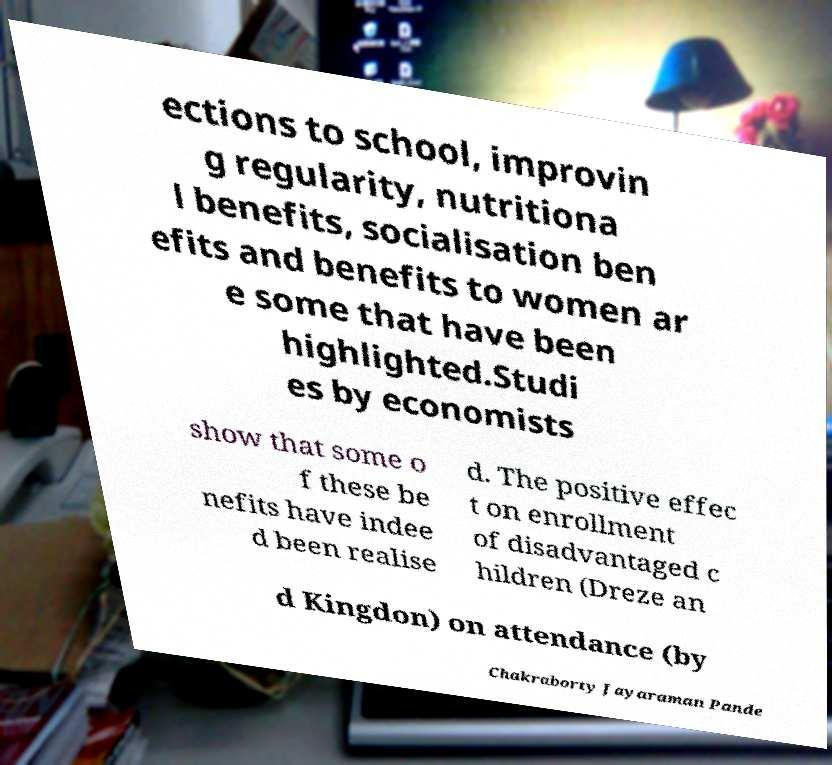Can you accurately transcribe the text from the provided image for me? ections to school, improvin g regularity, nutritiona l benefits, socialisation ben efits and benefits to women ar e some that have been highlighted.Studi es by economists show that some o f these be nefits have indee d been realise d. The positive effec t on enrollment of disadvantaged c hildren (Dreze an d Kingdon) on attendance (by Chakraborty Jayaraman Pande 